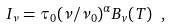<formula> <loc_0><loc_0><loc_500><loc_500>I _ { \nu } = \tau _ { 0 } ( \nu / \nu _ { 0 } ) ^ { \alpha } B _ { v } ( T ) \ ,</formula> 